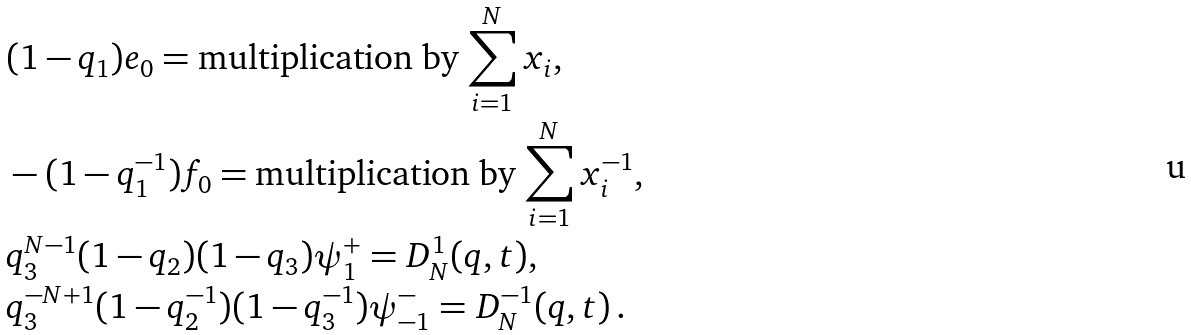Convert formula to latex. <formula><loc_0><loc_0><loc_500><loc_500>& ( 1 - q _ { 1 } ) e _ { 0 } = \text {multiplication by $\sum_{i=1}^{N}x_{i}$} , \\ & - ( 1 - q _ { 1 } ^ { - 1 } ) f _ { 0 } = \text {multiplication by $\sum_{i=1}^{N}x_{i}^{-1}$} , \\ & q _ { 3 } ^ { N - 1 } ( 1 - q _ { 2 } ) ( 1 - q _ { 3 } ) \psi ^ { + } _ { 1 } = D ^ { 1 } _ { N } ( q , t ) , \\ & q _ { 3 } ^ { - N + 1 } ( 1 - q _ { 2 } ^ { - 1 } ) ( 1 - q _ { 3 } ^ { - 1 } ) \psi ^ { - } _ { - 1 } = D ^ { - 1 } _ { N } ( q , t ) \, .</formula> 